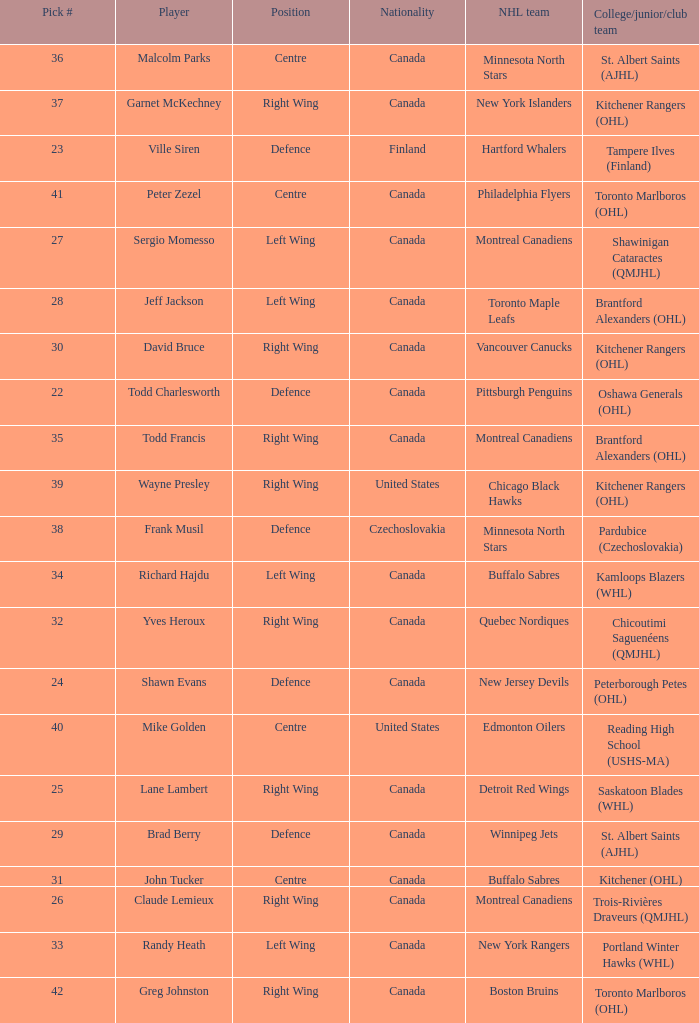What is the pick # when the nhl team is montreal canadiens and the college/junior/club team is trois-rivières draveurs (qmjhl)? 26.0. 